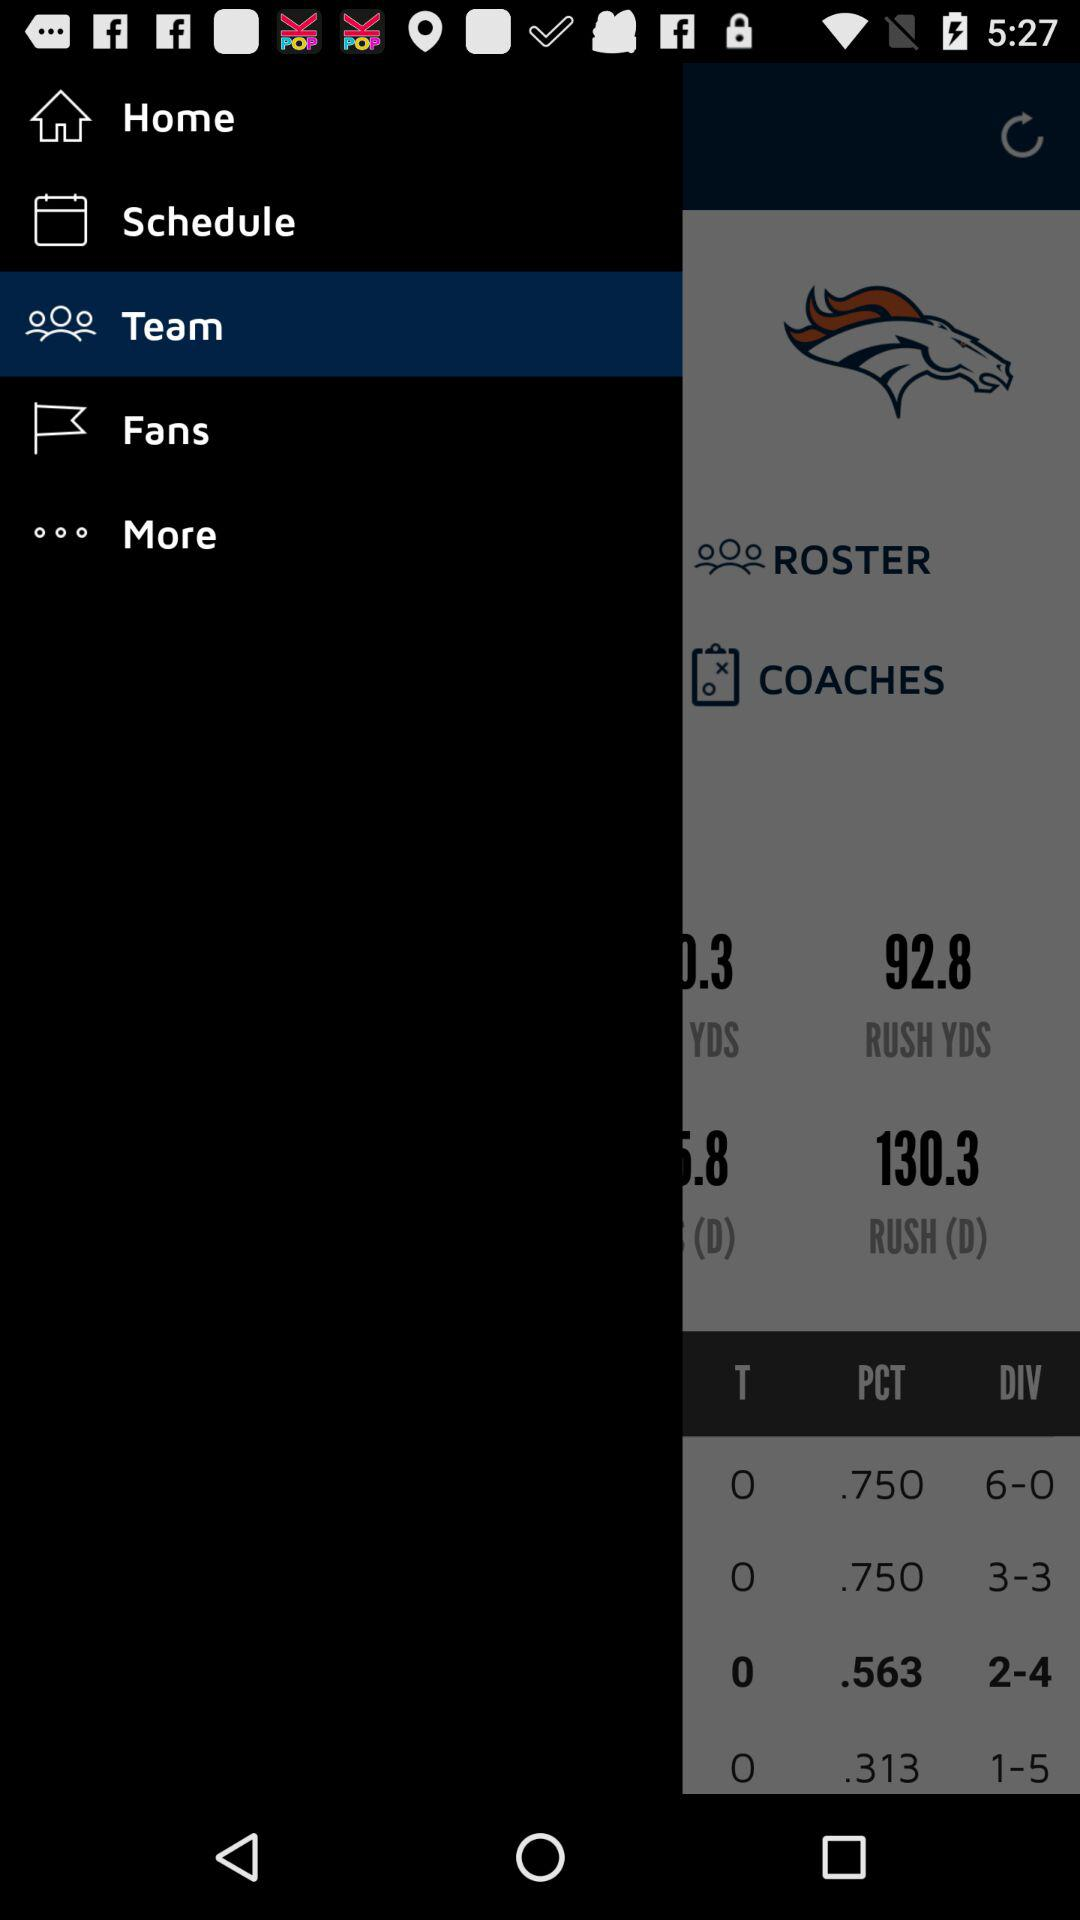How many more wins does the team with the best record have than the team with the worst record?
Answer the question using a single word or phrase. 5 